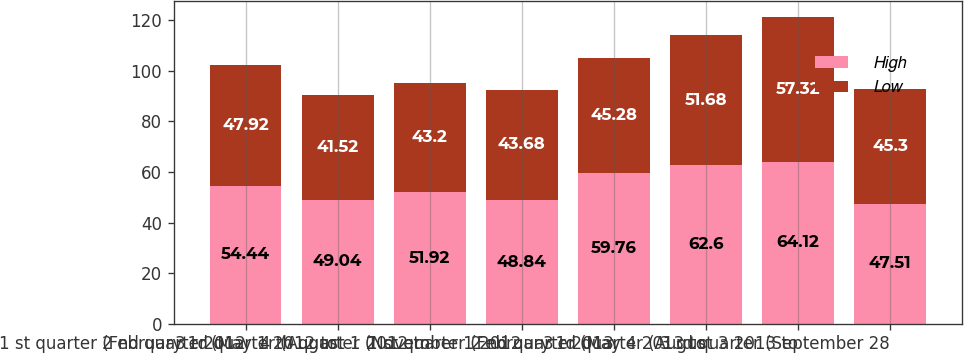<chart> <loc_0><loc_0><loc_500><loc_500><stacked_bar_chart><ecel><fcel>1 st quarter (February 1 2012<fcel>2 nd quarter (May 1 2012 to<fcel>3 rd quarter (August 1 2012 to<fcel>4 th quarter (November 1 2012<fcel>1 st quarter (February 1 2013<fcel>2 nd quarter (May 4 2013 to<fcel>3 rd quarter (August 3 2013 to<fcel>3 rd quarter (September 28<nl><fcel>High<fcel>54.44<fcel>49.04<fcel>51.92<fcel>48.84<fcel>59.76<fcel>62.6<fcel>64.12<fcel>47.51<nl><fcel>Low<fcel>47.92<fcel>41.52<fcel>43.2<fcel>43.68<fcel>45.28<fcel>51.68<fcel>57.32<fcel>45.3<nl></chart> 